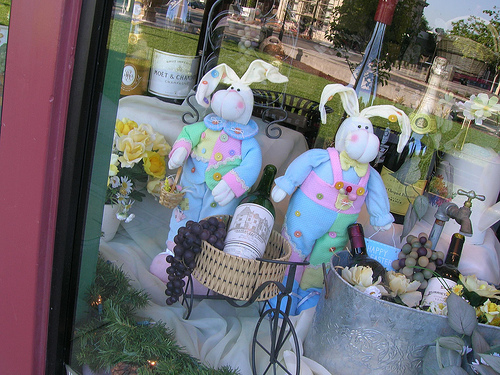<image>
Is there a wine in the basket? Yes. The wine is contained within or inside the basket, showing a containment relationship. 